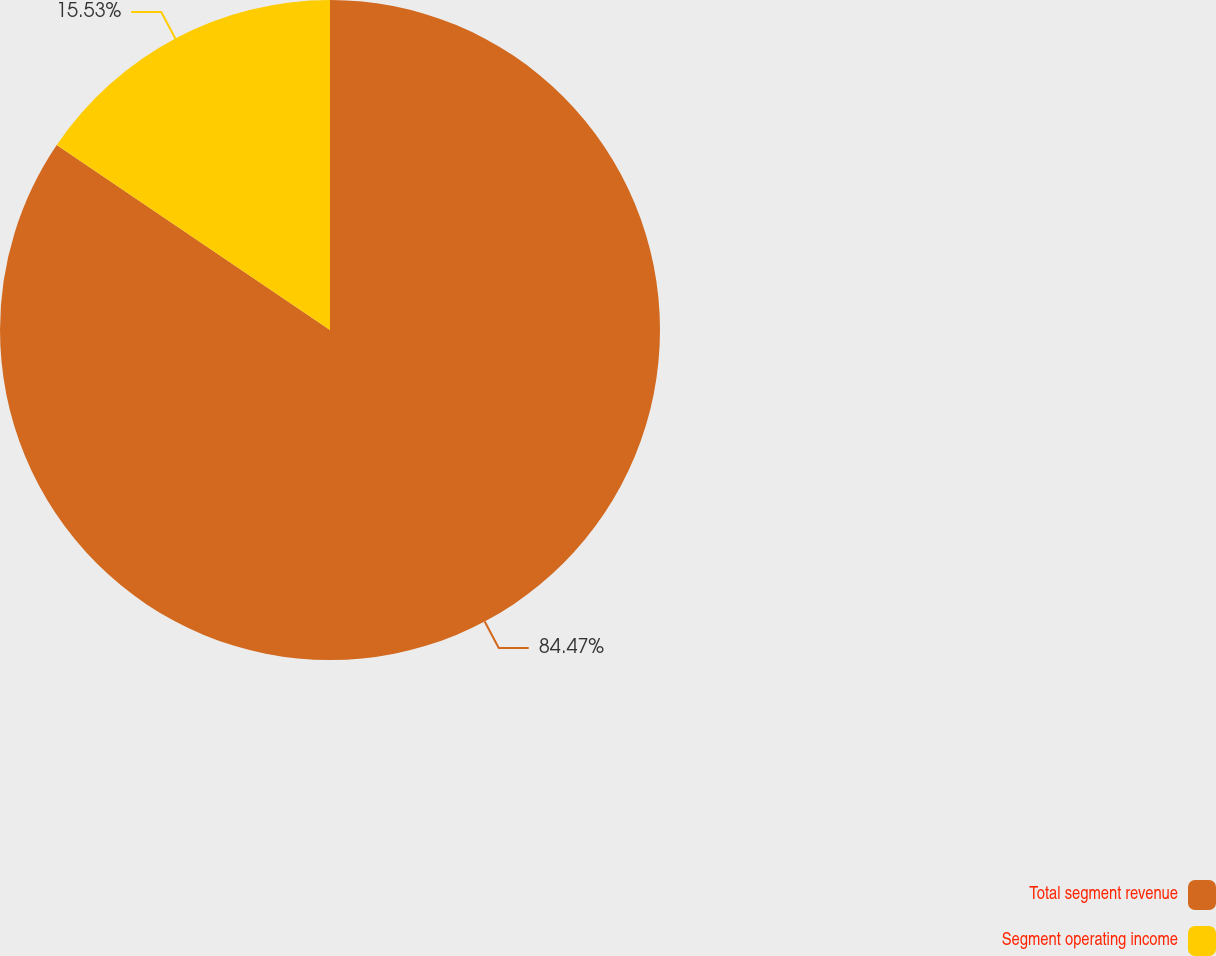Convert chart. <chart><loc_0><loc_0><loc_500><loc_500><pie_chart><fcel>Total segment revenue<fcel>Segment operating income<nl><fcel>84.47%<fcel>15.53%<nl></chart> 